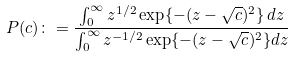Convert formula to latex. <formula><loc_0><loc_0><loc_500><loc_500>P ( c ) \colon = \frac { \int _ { 0 } ^ { \infty } z ^ { 1 / 2 } \exp \{ - ( z - \sqrt { c } ) ^ { 2 } \} \, d z } { \int _ { 0 } ^ { \infty } z ^ { - 1 / 2 } \exp \{ - ( z - \sqrt { c } ) ^ { 2 } \} d z }</formula> 